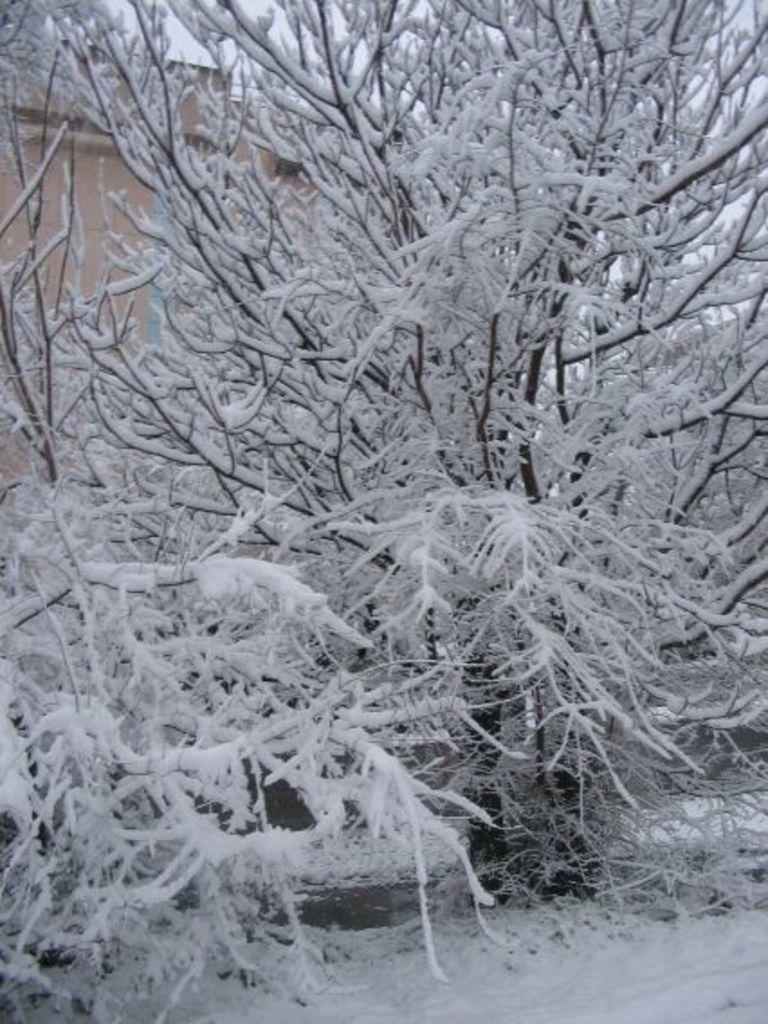What is the primary feature at the bottom of the image? There is snow at the bottom of the image. What can be seen in the middle of the image? Trees covered with snow are present in the middle of the image. What is visible in the background of the image? There is a building visible in the background of the image. What type of lunch is being prepared in the image? There is no indication of lunch preparation in the image. 